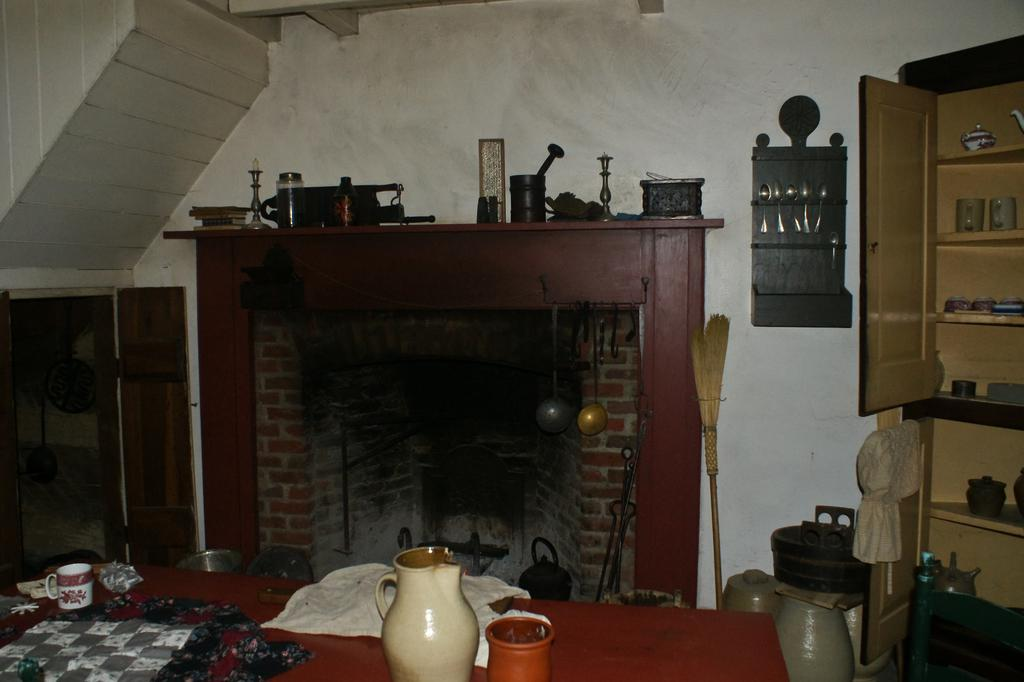What is on the table in the image? There is a jar and a cup on the table in the image. What else can be seen on the table besides the jar and cup? There are spoons visible on the table. What type of material is visible in the image? There is cloth visible in the image. What is the background of the image? The background of the image includes a wall. What type of storage furniture is present in the image? There is a cupboard in the image. What type of jeans is the person wearing in the image? There is no person visible in the image, so it is not possible to determine what type of jeans they might be wearing. 